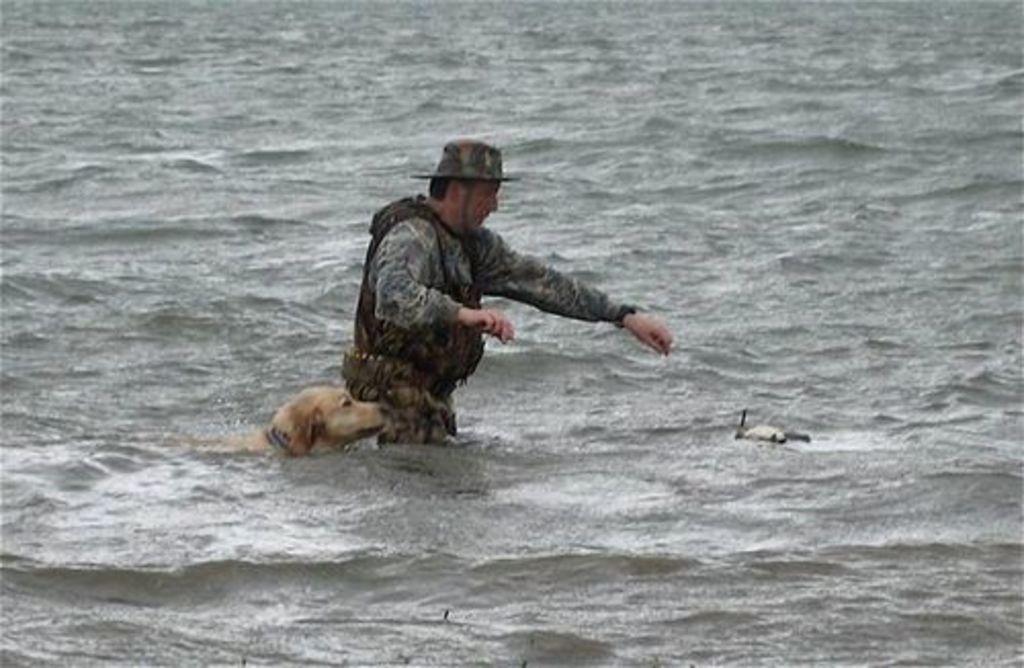Please provide a concise description of this image. In this image there is a person and a dog in the water. 